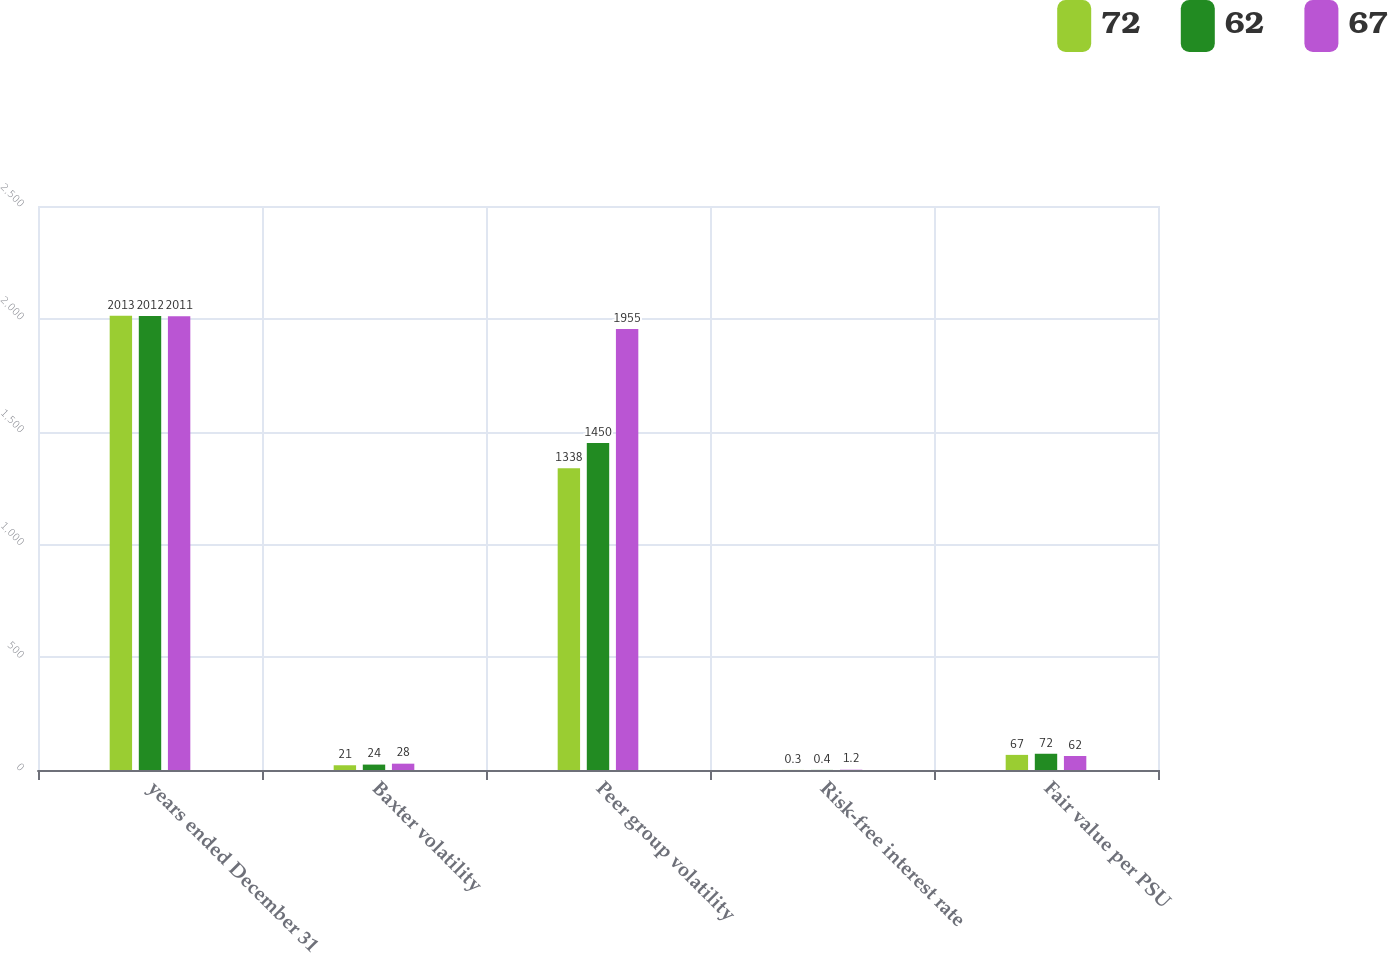<chart> <loc_0><loc_0><loc_500><loc_500><stacked_bar_chart><ecel><fcel>years ended December 31<fcel>Baxter volatility<fcel>Peer group volatility<fcel>Risk-free interest rate<fcel>Fair value per PSU<nl><fcel>72<fcel>2013<fcel>21<fcel>1338<fcel>0.3<fcel>67<nl><fcel>62<fcel>2012<fcel>24<fcel>1450<fcel>0.4<fcel>72<nl><fcel>67<fcel>2011<fcel>28<fcel>1955<fcel>1.2<fcel>62<nl></chart> 